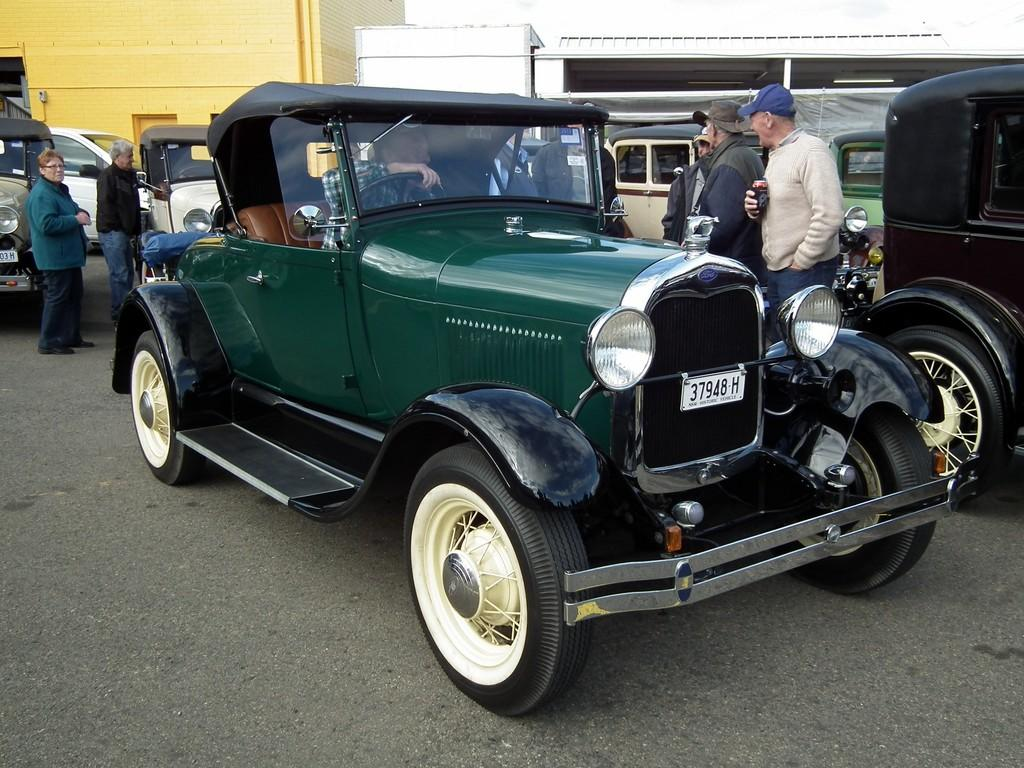What type of vehicle is in the image? There is a jeep with a number plate in the image. What is happening around the jeep? There are many people near the jeep, and some of them are wearing caps. What can be seen in the background of the image? There are many vehicles and buildings visible in the background of the image. What type of fruit is being carried by the beast in the image? There is no beast or fruit present in the image. 